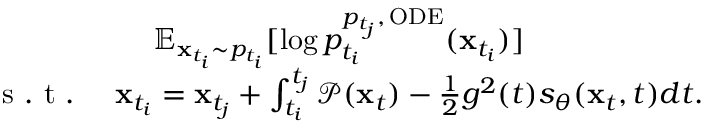Convert formula to latex. <formula><loc_0><loc_0><loc_500><loc_500>\begin{array} { r } { \mathbb { E } _ { x _ { t _ { i } } \sim p _ { t _ { i } } } [ \log p _ { t _ { i } } ^ { p _ { t _ { j } } , \, O D E } ( x _ { t _ { i } } ) ] \quad } \\ { s . t . \quad x _ { t _ { i } } = x _ { t _ { j } } + \int _ { t _ { i } } ^ { t _ { j } } \mathcal { P } ( x _ { t } ) - \frac { 1 } { 2 } g ^ { 2 } ( t ) s _ { \theta } ( x _ { t } , t ) d t . } \end{array}</formula> 